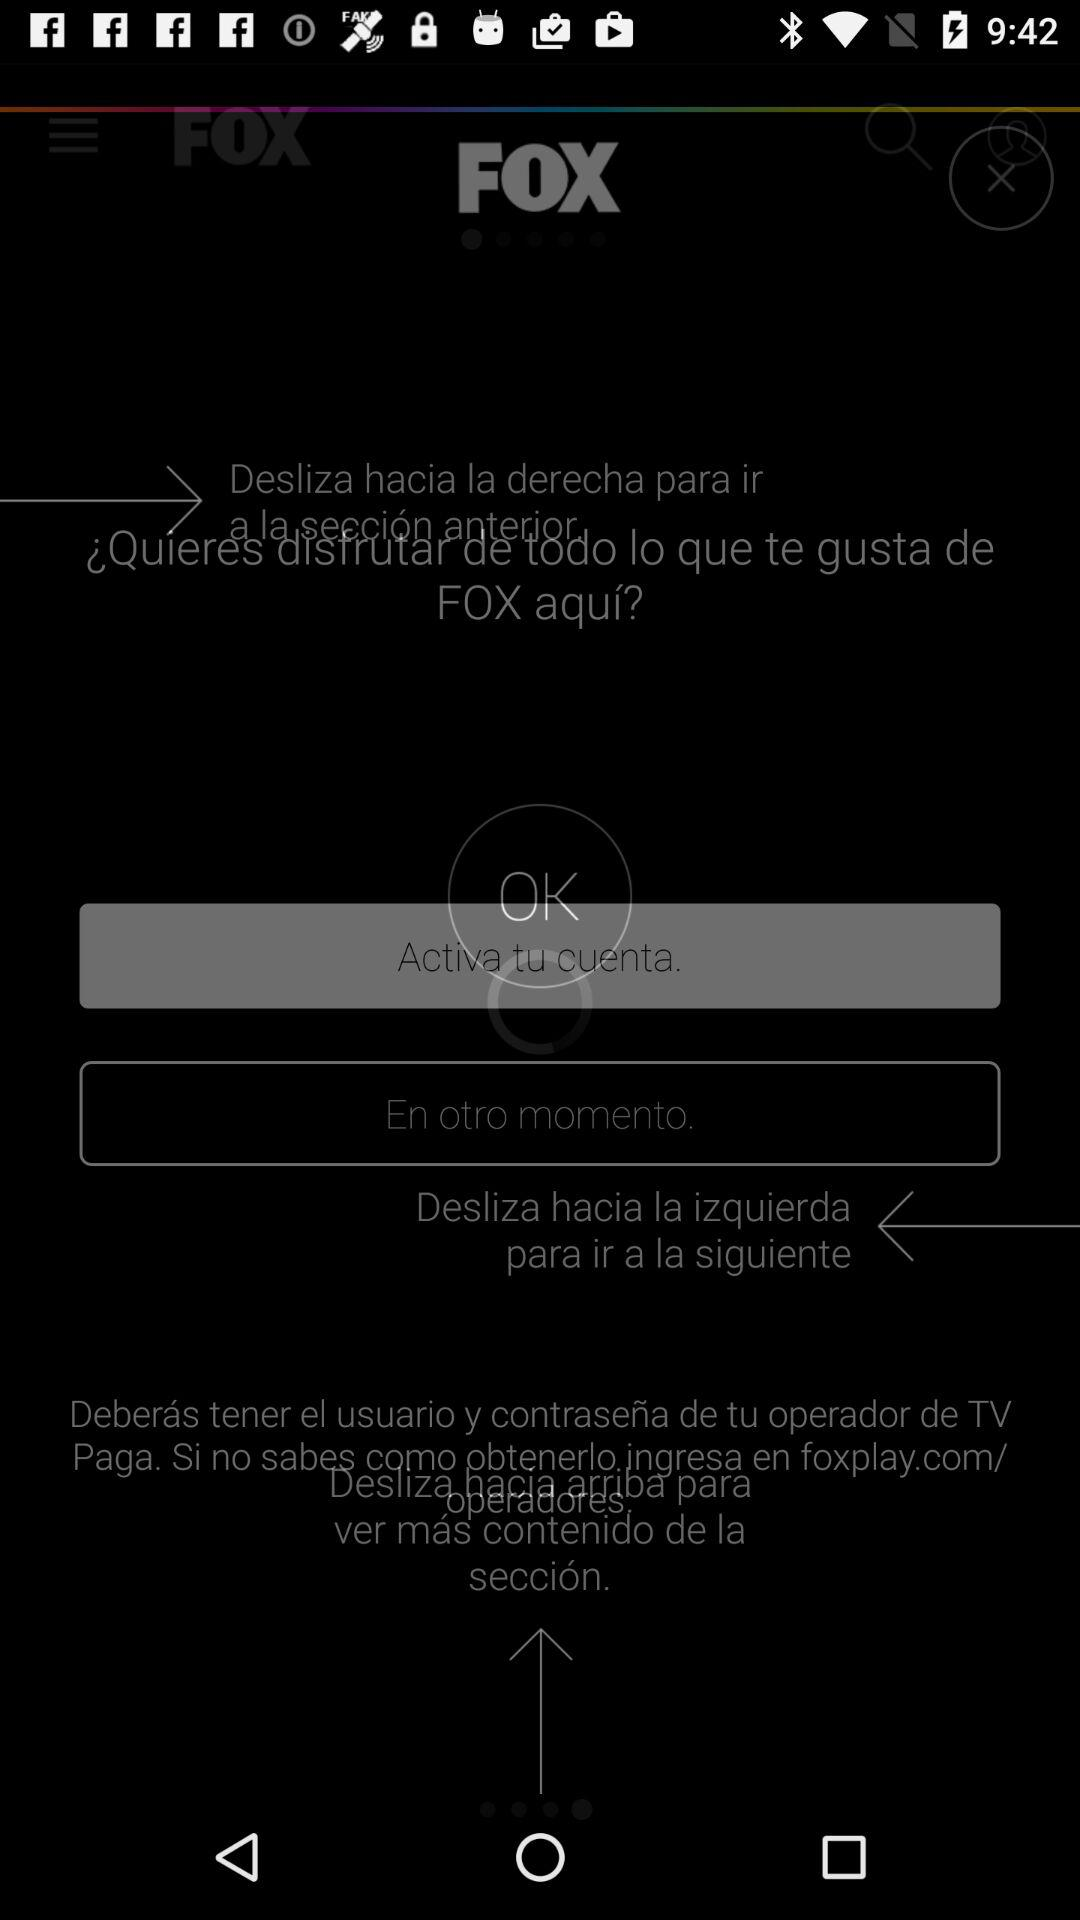Who is this application powered by?
When the provided information is insufficient, respond with <no answer>. <no answer> 